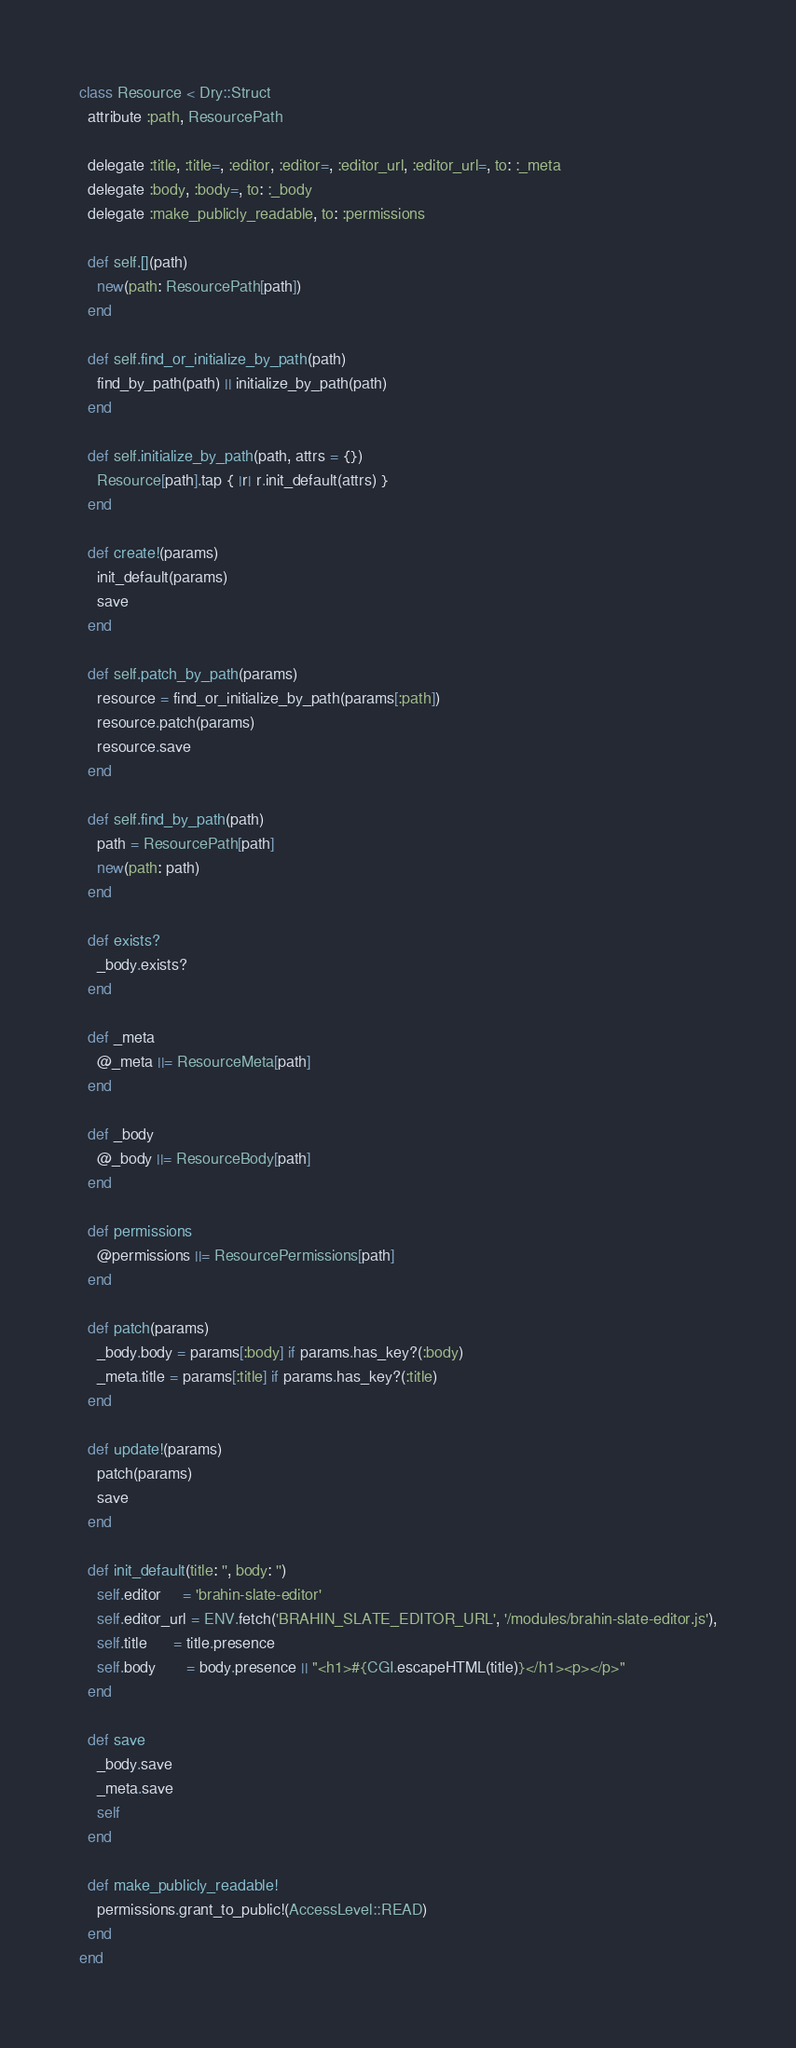Convert code to text. <code><loc_0><loc_0><loc_500><loc_500><_Ruby_>class Resource < Dry::Struct
  attribute :path, ResourcePath

  delegate :title, :title=, :editor, :editor=, :editor_url, :editor_url=, to: :_meta
  delegate :body, :body=, to: :_body
  delegate :make_publicly_readable, to: :permissions

  def self.[](path)
    new(path: ResourcePath[path])
  end

  def self.find_or_initialize_by_path(path)
    find_by_path(path) || initialize_by_path(path)
  end

  def self.initialize_by_path(path, attrs = {})
    Resource[path].tap { |r| r.init_default(attrs) }
  end

  def create!(params)
    init_default(params)
    save
  end

  def self.patch_by_path(params)
    resource = find_or_initialize_by_path(params[:path])
    resource.patch(params)
    resource.save
  end

  def self.find_by_path(path)
    path = ResourcePath[path]
    new(path: path)
  end

  def exists?
    _body.exists?
  end

  def _meta
    @_meta ||= ResourceMeta[path]
  end

  def _body
    @_body ||= ResourceBody[path]
  end

  def permissions
    @permissions ||= ResourcePermissions[path]
  end

  def patch(params)
    _body.body = params[:body] if params.has_key?(:body)
    _meta.title = params[:title] if params.has_key?(:title)
  end

  def update!(params)
    patch(params)
    save
  end

  def init_default(title: '', body: '')
    self.editor     = 'brahin-slate-editor'
    self.editor_url = ENV.fetch('BRAHIN_SLATE_EDITOR_URL', '/modules/brahin-slate-editor.js'),
    self.title      = title.presence
    self.body       = body.presence || "<h1>#{CGI.escapeHTML(title)}</h1><p></p>"
  end

  def save
    _body.save
    _meta.save
    self
  end

  def make_publicly_readable!
    permissions.grant_to_public!(AccessLevel::READ)
  end
end
</code> 